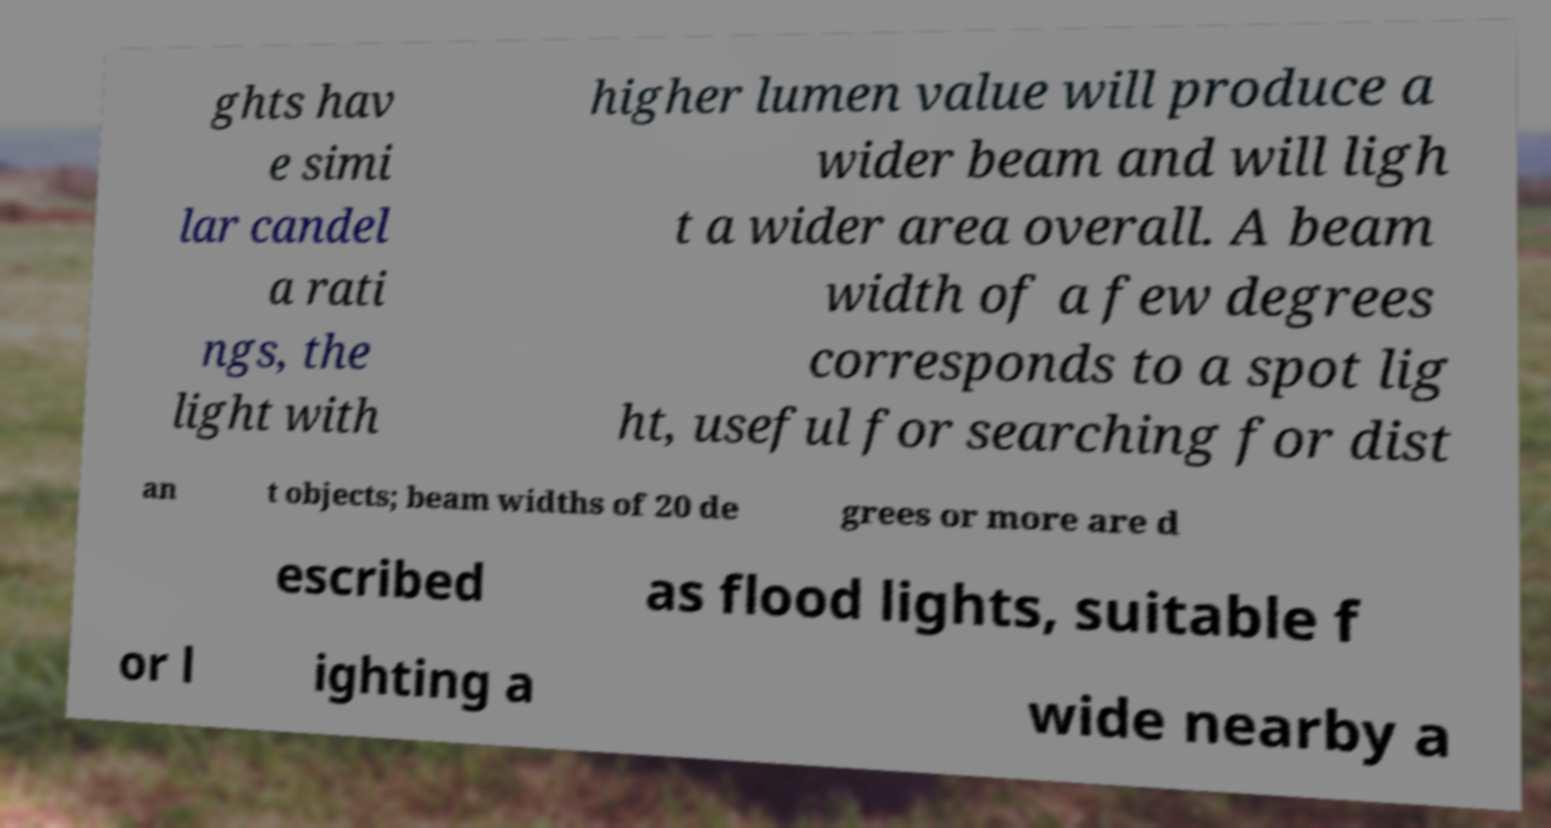For documentation purposes, I need the text within this image transcribed. Could you provide that? ghts hav e simi lar candel a rati ngs, the light with higher lumen value will produce a wider beam and will ligh t a wider area overall. A beam width of a few degrees corresponds to a spot lig ht, useful for searching for dist an t objects; beam widths of 20 de grees or more are d escribed as flood lights, suitable f or l ighting a wide nearby a 